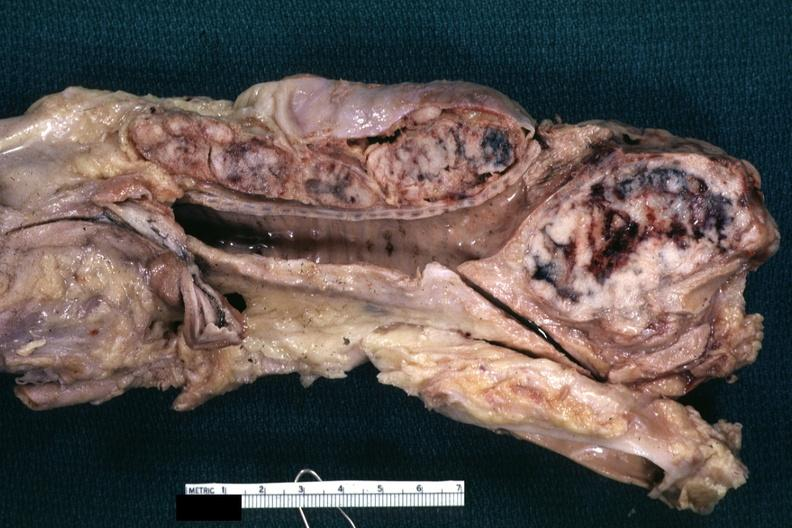what is present?
Answer the question using a single word or phrase. Metastatic carcinoma 